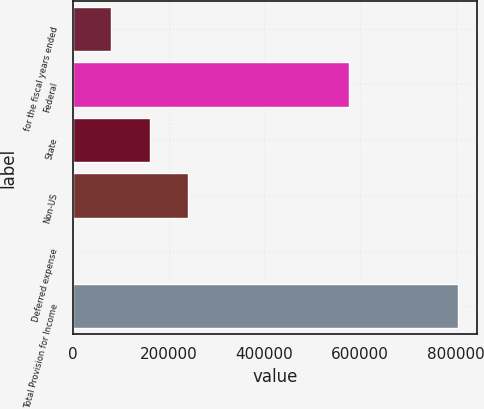Convert chart to OTSL. <chart><loc_0><loc_0><loc_500><loc_500><bar_chart><fcel>for the fiscal years ended<fcel>Federal<fcel>State<fcel>Non-US<fcel>Deferred expense<fcel>Total Provision for Income<nl><fcel>80715<fcel>576418<fcel>161016<fcel>241317<fcel>414<fcel>803424<nl></chart> 